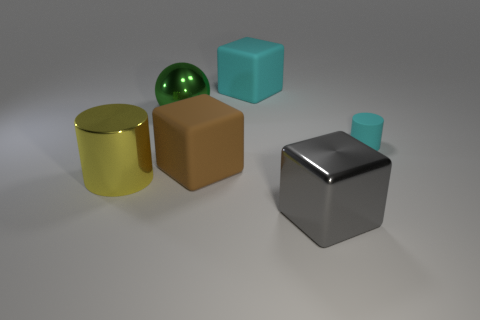The green object has what size?
Make the answer very short. Large. There is a green metal thing; what shape is it?
Provide a succinct answer. Sphere. Are there any other things that have the same shape as the green thing?
Offer a very short reply. No. Are there fewer green metal things that are in front of the big shiny sphere than large metallic cylinders?
Provide a succinct answer. Yes. Do the metal object behind the shiny cylinder and the tiny matte thing have the same color?
Provide a succinct answer. No. What number of metallic things are either large brown cylinders or small cylinders?
Your response must be concise. 0. Are there any other things that have the same size as the rubber cylinder?
Your response must be concise. No. What color is the tiny cylinder that is made of the same material as the large brown block?
Offer a very short reply. Cyan. How many balls are either yellow metallic objects or big brown things?
Provide a succinct answer. 0. How many things are red spheres or blocks behind the yellow metallic thing?
Give a very brief answer. 2. 